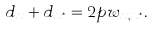<formula> <loc_0><loc_0><loc_500><loc_500>d _ { x } + d _ { x ^ { * } } = 2 p w _ { x , x ^ { * } } .</formula> 